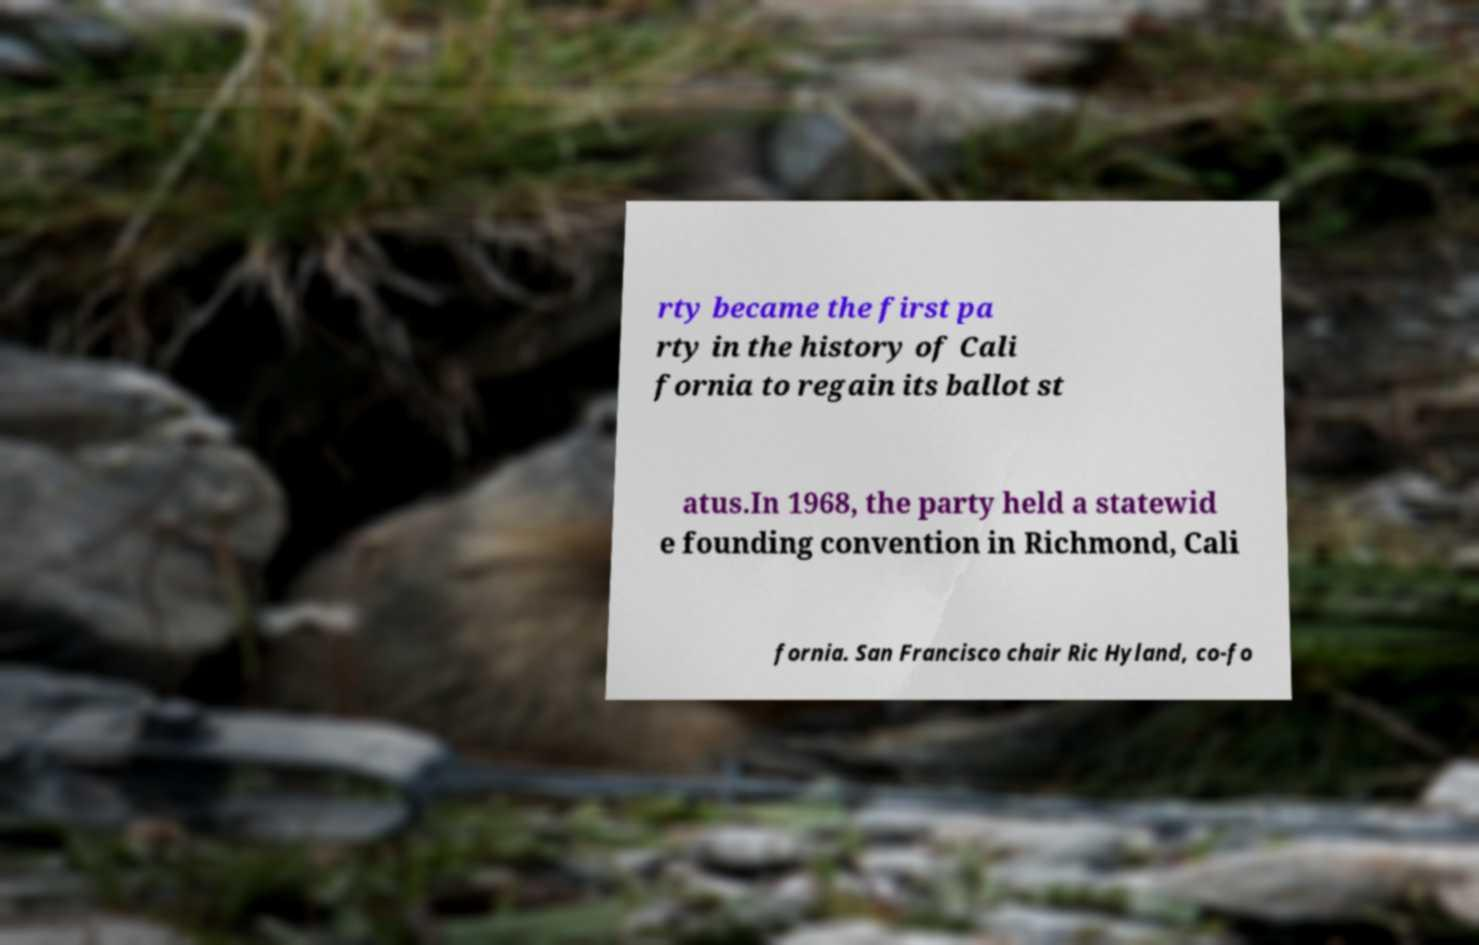Could you extract and type out the text from this image? rty became the first pa rty in the history of Cali fornia to regain its ballot st atus.In 1968, the party held a statewid e founding convention in Richmond, Cali fornia. San Francisco chair Ric Hyland, co-fo 